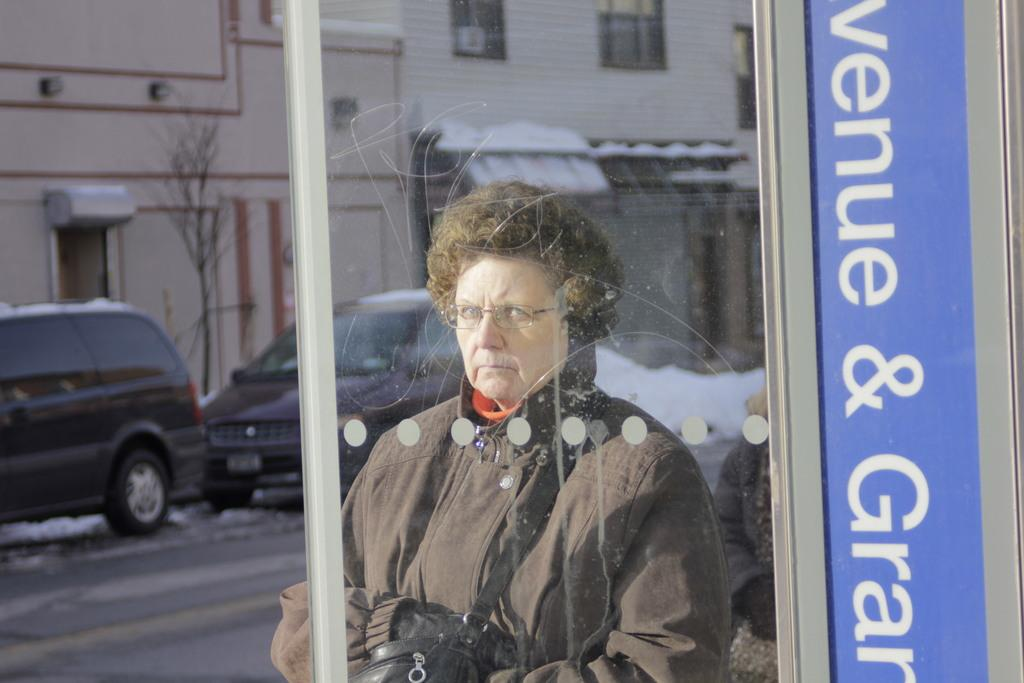Who is present in the image? There is a woman in the image. What is the woman wearing? The woman is wearing a coat. What is the woman carrying? The woman is carrying a bag. What accessory is the woman wearing? The woman is wearing spectacles. What can be seen in the background of the image? There are vehicles parked, buildings, and trees in the background. What type of music can be heard playing in the background of the image? There is no music present in the image, as it is a still photograph. Is there any indication of sleet in the image? There is no indication of sleet in the image; the weather conditions cannot be determined from the photograph. 